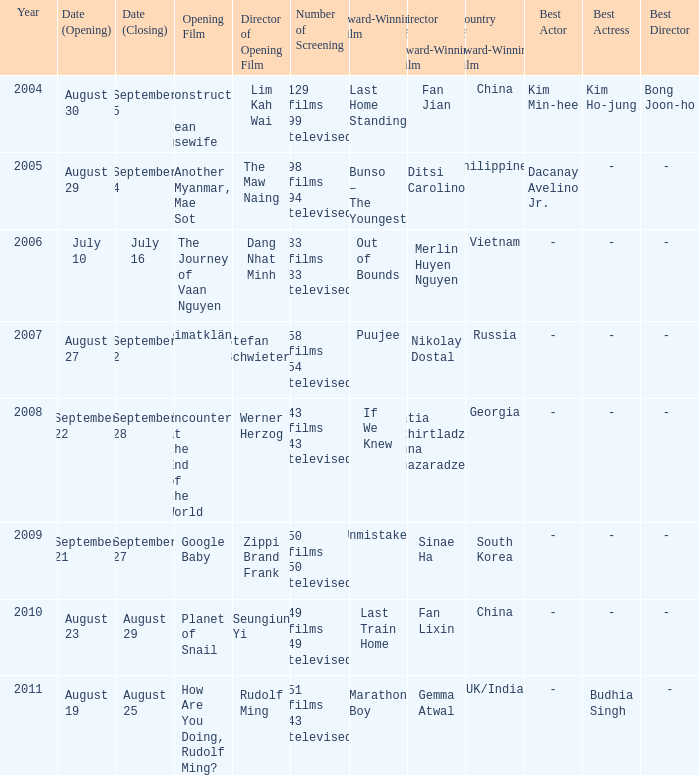Which acclaimed film concludes on september 4? Bunso – The Youngest. 